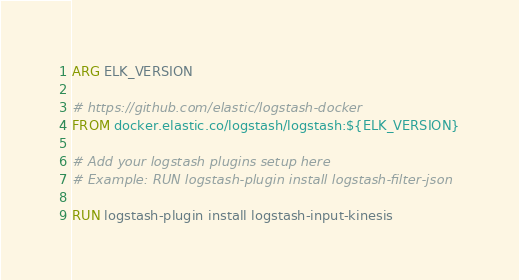Convert code to text. <code><loc_0><loc_0><loc_500><loc_500><_Dockerfile_>ARG ELK_VERSION

# https://github.com/elastic/logstash-docker
FROM docker.elastic.co/logstash/logstash:${ELK_VERSION}

# Add your logstash plugins setup here
# Example: RUN logstash-plugin install logstash-filter-json

RUN logstash-plugin install logstash-input-kinesis

</code> 